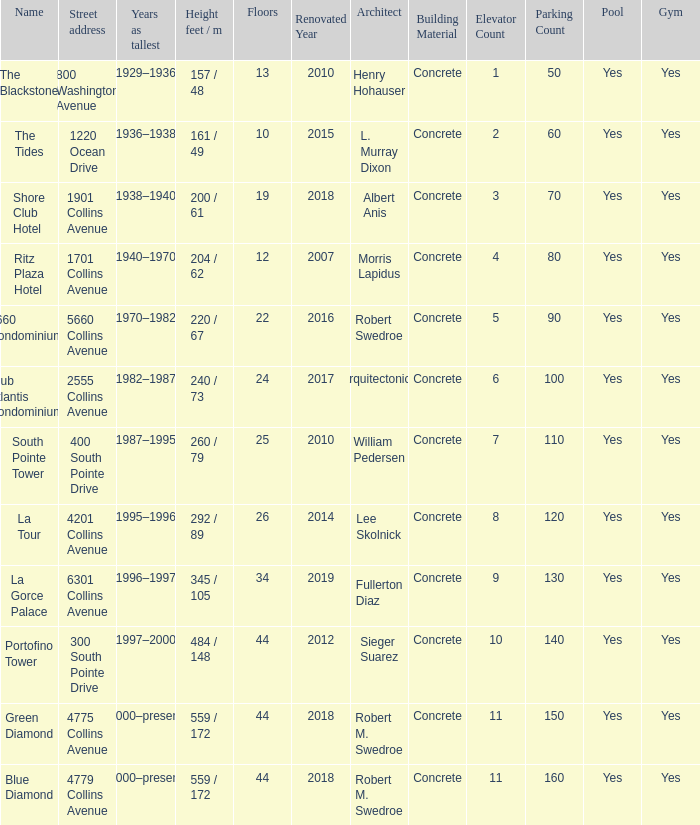How many years was the building with 24 floors the tallest? 1982–1987. 